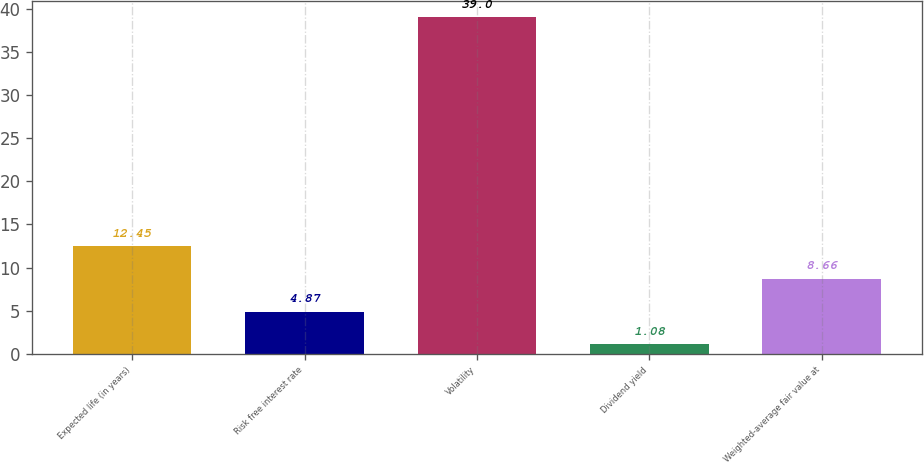Convert chart. <chart><loc_0><loc_0><loc_500><loc_500><bar_chart><fcel>Expected life (in years)<fcel>Risk free interest rate<fcel>Volatility<fcel>Dividend yield<fcel>Weighted-average fair value at<nl><fcel>12.45<fcel>4.87<fcel>39<fcel>1.08<fcel>8.66<nl></chart> 